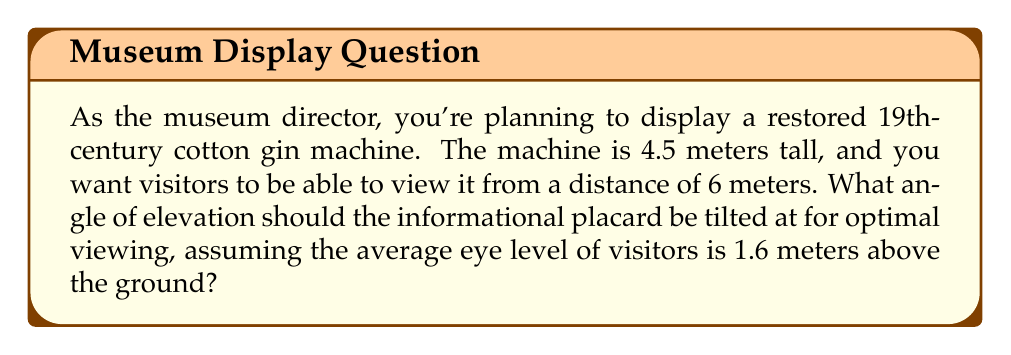Provide a solution to this math problem. To solve this problem, we need to use trigonometry. Let's break it down step-by-step:

1) First, let's visualize the scenario:

[asy]
import geometry;

pair A = (0,0), B = (6,0), C = (6,4.5), D = (6,1.6);
draw(A--B--C--A);
draw(A--D,dashed);
label("4.5m",A--C,W);
label("6m",A--B,S);
label("1.6m",B--D,E);
label("θ",A,NE);
dot("A",A,SW);
dot("B",B,SE);
dot("C",C,NE);
dot("D",D,E);
[/asy]

2) We need to find the angle θ, which is the angle of elevation from the eye level to the top of the machine.

3) The triangle we're interested in is ACD, where:
   - AC is the height of the machine (4.5m)
   - AD is the distance from the viewer to the machine (6m)
   - CD is the difference between the machine height and eye level (4.5m - 1.6m = 2.9m)

4) We can use the tangent function to find this angle:

   $$\tan(\theta) = \frac{\text{opposite}}{\text{adjacent}} = \frac{CD}{AD} = \frac{2.9}{6}$$

5) To find θ, we need to use the inverse tangent (arctan or tan^(-1)):

   $$\theta = \tan^{-1}(\frac{2.9}{6})$$

6) Using a calculator or computer:

   $$\theta \approx 25.78°$$

This is the angle of elevation from the eye level to the top of the machine. The informational placard should be tilted at this angle for optimal viewing.
Answer: The angle of elevation for the informational placard should be approximately $25.78°$. 